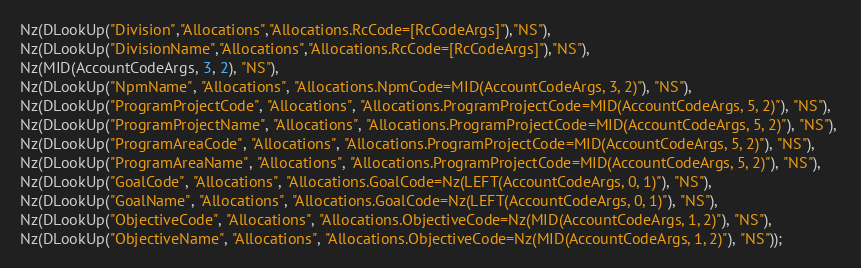Convert code to text. <code><loc_0><loc_0><loc_500><loc_500><_SQL_>Nz(DLookUp("Division","Allocations","Allocations.RcCode=[RcCodeArgs]"),"NS"), 
Nz(DLookUp("DivisionName","Allocations","Allocations.RcCode=[RcCodeArgs]"),"NS"), 
Nz(MID(AccountCodeArgs, 3, 2), "NS"), 
Nz(DLookUp("NpmName", "Allocations", "Allocations.NpmCode=MID(AccountCodeArgs, 3, 2)"), "NS"), 
Nz(DLookUp("ProgramProjectCode", "Allocations", "Allocations.ProgramProjectCode=MID(AccountCodeArgs, 5, 2)"), "NS"), 
Nz(DLookUp("ProgramProjectName", "Allocations", "Allocations.ProgramProjectCode=MID(AccountCodeArgs, 5, 2)"), "NS"), 
Nz(DLookUp("ProgramAreaCode", "Allocations", "Allocations.ProgramProjectCode=MID(AccountCodeArgs, 5, 2)"), "NS"), 
Nz(DLookUp("ProgramAreaName", "Allocations", "Allocations.ProgramProjectCode=MID(AccountCodeArgs, 5, 2)"), "NS"), 
Nz(DLookUp("GoalCode", "Allocations", "Allocations.GoalCode=Nz(LEFT(AccountCodeArgs, 0, 1)"), "NS"), 
Nz(DLookUp("GoalName", "Allocations", "Allocations.GoalCode=Nz(LEFT(AccountCodeArgs, 0, 1)"), "NS"), 
Nz(DLookUp("ObjectiveCode", "Allocations", "Allocations.ObjectiveCode=Nz(MID(AccountCodeArgs, 1, 2)"), "NS"), 
Nz(DLookUp("ObjectiveName", "Allocations", "Allocations.ObjectiveCode=Nz(MID(AccountCodeArgs, 1, 2)"), "NS"));</code> 